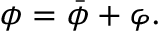<formula> <loc_0><loc_0><loc_500><loc_500>\phi = \bar { \phi } + \varphi .</formula> 